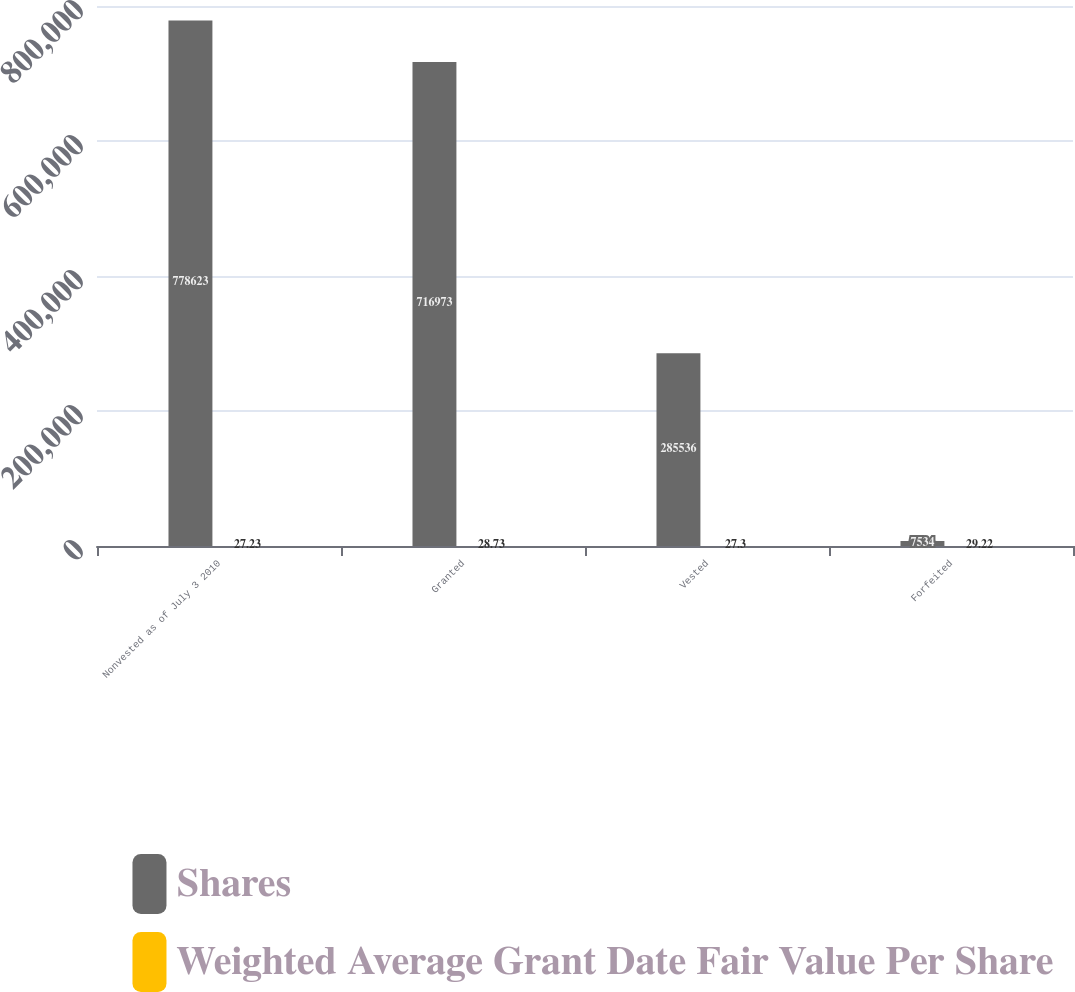<chart> <loc_0><loc_0><loc_500><loc_500><stacked_bar_chart><ecel><fcel>Nonvested as of July 3 2010<fcel>Granted<fcel>Vested<fcel>Forfeited<nl><fcel>Shares<fcel>778623<fcel>716973<fcel>285536<fcel>7534<nl><fcel>Weighted Average Grant Date Fair Value Per Share<fcel>27.23<fcel>28.73<fcel>27.3<fcel>29.22<nl></chart> 